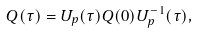<formula> <loc_0><loc_0><loc_500><loc_500>Q ( \tau ) = U _ { p } ( \tau ) Q ( 0 ) U _ { p } ^ { - 1 } ( \tau ) ,</formula> 